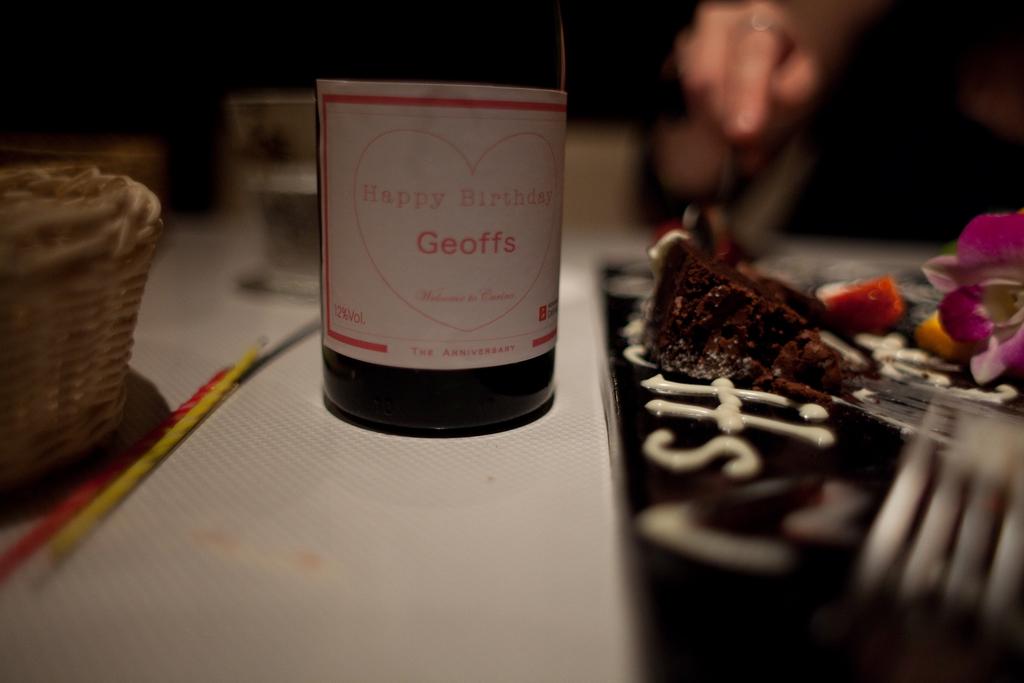What does this label say?
Make the answer very short. Happy birthday geoffs. Who's birthday is it?
Make the answer very short. Geoffs. 